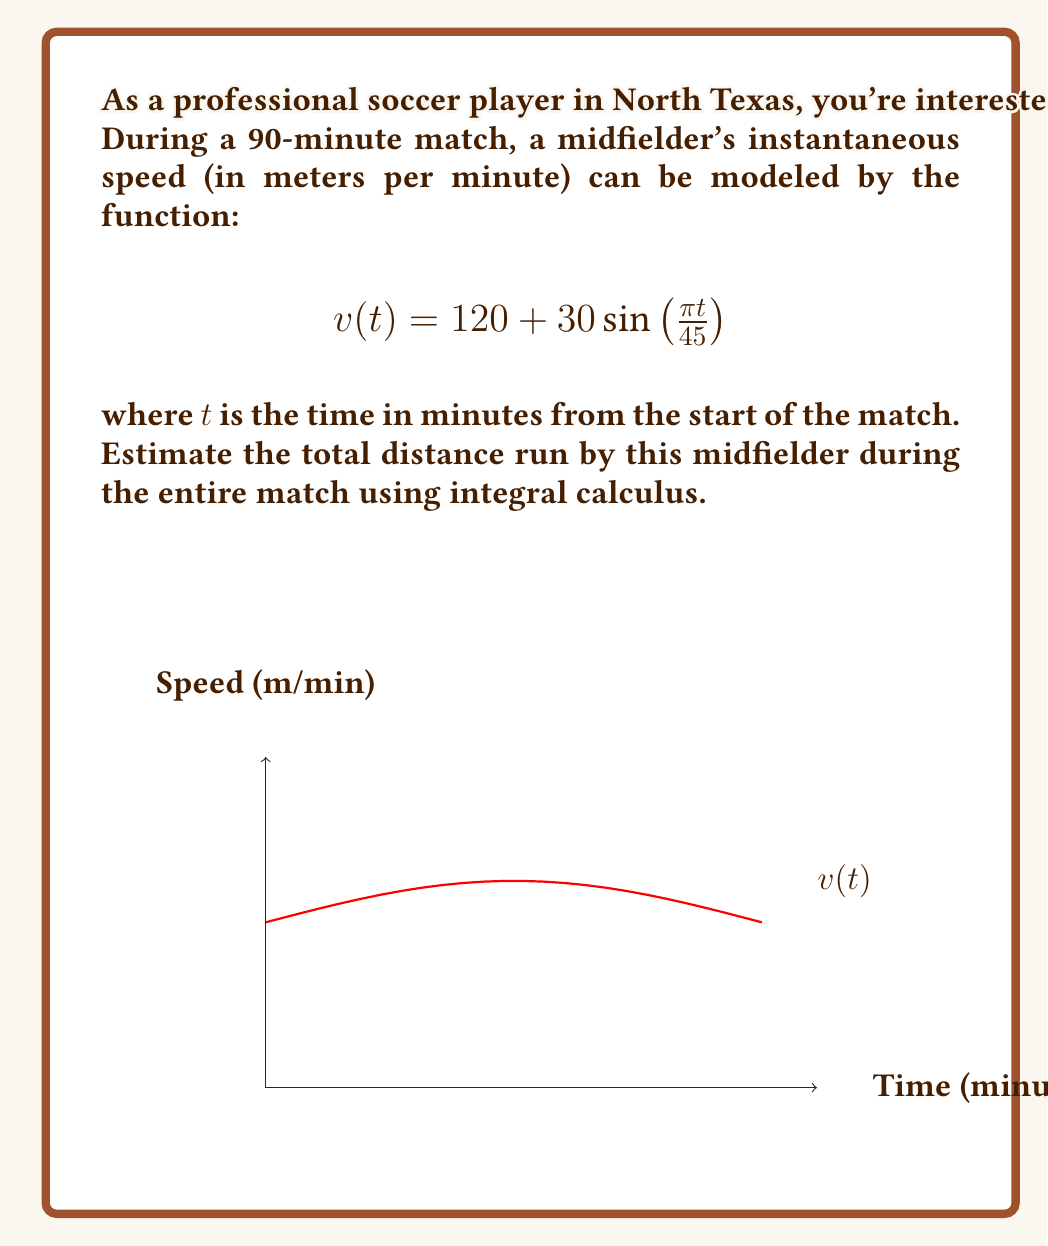Show me your answer to this math problem. To solve this problem, we need to follow these steps:

1) The total distance run is equal to the area under the velocity-time curve. We can calculate this using a definite integral from $t=0$ to $t=90$ (the duration of the match).

2) The integral we need to evaluate is:

   $$\int_0^{90} v(t) dt = \int_0^{90} (120 + 30\sin(\frac{\pi t}{45})) dt$$

3) Let's break this into two parts:

   $$\int_0^{90} 120 dt + \int_0^{90} 30\sin(\frac{\pi t}{45}) dt$$

4) For the first part:
   
   $$\int_0^{90} 120 dt = 120t \big|_0^{90} = 120 \cdot 90 = 10800$$

5) For the second part, we use the substitution $u = \frac{\pi t}{45}$:
   
   $$\int_0^{90} 30\sin(\frac{\pi t}{45}) dt = \frac{30 \cdot 45}{\pi} \int_0^{2\pi} \sin(u) du = \frac{1350}{\pi} [-\cos(u)]_0^{2\pi} = 0$$

6) Adding the results from steps 4 and 5:

   Total distance = 10800 + 0 = 10800 meters

Therefore, the midfielder ran approximately 10800 meters or 10.8 kilometers during the match.
Answer: 10.8 km 